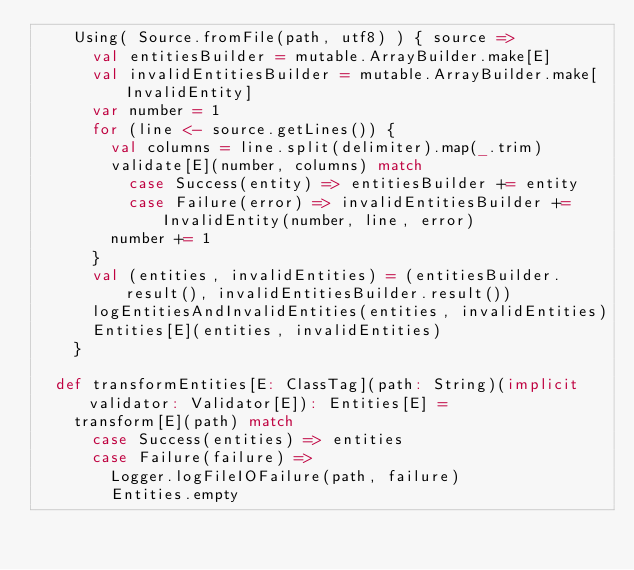<code> <loc_0><loc_0><loc_500><loc_500><_Scala_>    Using( Source.fromFile(path, utf8) ) { source =>
      val entitiesBuilder = mutable.ArrayBuilder.make[E]
      val invalidEntitiesBuilder = mutable.ArrayBuilder.make[InvalidEntity]
      var number = 1
      for (line <- source.getLines()) {
        val columns = line.split(delimiter).map(_.trim)
        validate[E](number, columns) match
          case Success(entity) => entitiesBuilder += entity
          case Failure(error) => invalidEntitiesBuilder += InvalidEntity(number, line, error)
        number += 1
      }
      val (entities, invalidEntities) = (entitiesBuilder.result(), invalidEntitiesBuilder.result())
      logEntitiesAndInvalidEntities(entities, invalidEntities)
      Entities[E](entities, invalidEntities)
    }

  def transformEntities[E: ClassTag](path: String)(implicit validator: Validator[E]): Entities[E] =
    transform[E](path) match
      case Success(entities) => entities
      case Failure(failure) =>
        Logger.logFileIOFailure(path, failure)
        Entities.empty</code> 